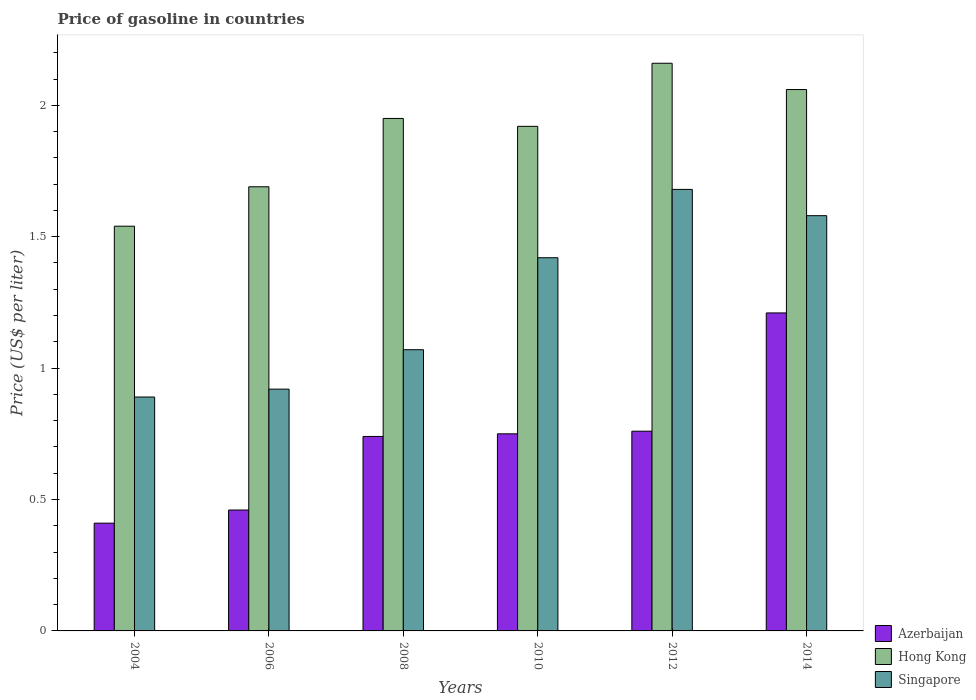How many different coloured bars are there?
Keep it short and to the point. 3. How many groups of bars are there?
Your response must be concise. 6. Are the number of bars per tick equal to the number of legend labels?
Make the answer very short. Yes. Are the number of bars on each tick of the X-axis equal?
Offer a very short reply. Yes. How many bars are there on the 2nd tick from the left?
Provide a short and direct response. 3. What is the label of the 1st group of bars from the left?
Provide a succinct answer. 2004. What is the price of gasoline in Hong Kong in 2008?
Make the answer very short. 1.95. Across all years, what is the maximum price of gasoline in Hong Kong?
Your answer should be compact. 2.16. Across all years, what is the minimum price of gasoline in Singapore?
Your answer should be very brief. 0.89. In which year was the price of gasoline in Azerbaijan maximum?
Ensure brevity in your answer.  2014. In which year was the price of gasoline in Hong Kong minimum?
Offer a terse response. 2004. What is the total price of gasoline in Hong Kong in the graph?
Give a very brief answer. 11.32. What is the difference between the price of gasoline in Azerbaijan in 2006 and that in 2010?
Your response must be concise. -0.29. What is the difference between the price of gasoline in Hong Kong in 2008 and the price of gasoline in Azerbaijan in 2014?
Provide a succinct answer. 0.74. What is the average price of gasoline in Singapore per year?
Give a very brief answer. 1.26. In the year 2012, what is the difference between the price of gasoline in Azerbaijan and price of gasoline in Singapore?
Your response must be concise. -0.92. What is the ratio of the price of gasoline in Singapore in 2010 to that in 2014?
Provide a short and direct response. 0.9. Is the price of gasoline in Singapore in 2008 less than that in 2014?
Give a very brief answer. Yes. What is the difference between the highest and the second highest price of gasoline in Hong Kong?
Provide a short and direct response. 0.1. Is the sum of the price of gasoline in Singapore in 2010 and 2012 greater than the maximum price of gasoline in Azerbaijan across all years?
Provide a short and direct response. Yes. What does the 3rd bar from the left in 2010 represents?
Make the answer very short. Singapore. What does the 3rd bar from the right in 2012 represents?
Offer a very short reply. Azerbaijan. Is it the case that in every year, the sum of the price of gasoline in Hong Kong and price of gasoline in Azerbaijan is greater than the price of gasoline in Singapore?
Give a very brief answer. Yes. How many bars are there?
Your answer should be compact. 18. Does the graph contain any zero values?
Your response must be concise. No. Does the graph contain grids?
Offer a very short reply. No. How many legend labels are there?
Offer a terse response. 3. What is the title of the graph?
Make the answer very short. Price of gasoline in countries. Does "Sierra Leone" appear as one of the legend labels in the graph?
Keep it short and to the point. No. What is the label or title of the X-axis?
Ensure brevity in your answer.  Years. What is the label or title of the Y-axis?
Offer a terse response. Price (US$ per liter). What is the Price (US$ per liter) of Azerbaijan in 2004?
Keep it short and to the point. 0.41. What is the Price (US$ per liter) in Hong Kong in 2004?
Your answer should be very brief. 1.54. What is the Price (US$ per liter) of Singapore in 2004?
Provide a short and direct response. 0.89. What is the Price (US$ per liter) in Azerbaijan in 2006?
Your answer should be compact. 0.46. What is the Price (US$ per liter) in Hong Kong in 2006?
Offer a very short reply. 1.69. What is the Price (US$ per liter) in Singapore in 2006?
Give a very brief answer. 0.92. What is the Price (US$ per liter) in Azerbaijan in 2008?
Your answer should be compact. 0.74. What is the Price (US$ per liter) of Hong Kong in 2008?
Your response must be concise. 1.95. What is the Price (US$ per liter) in Singapore in 2008?
Your answer should be very brief. 1.07. What is the Price (US$ per liter) in Azerbaijan in 2010?
Your answer should be compact. 0.75. What is the Price (US$ per liter) of Hong Kong in 2010?
Give a very brief answer. 1.92. What is the Price (US$ per liter) in Singapore in 2010?
Your answer should be very brief. 1.42. What is the Price (US$ per liter) of Azerbaijan in 2012?
Provide a succinct answer. 0.76. What is the Price (US$ per liter) of Hong Kong in 2012?
Offer a very short reply. 2.16. What is the Price (US$ per liter) of Singapore in 2012?
Offer a very short reply. 1.68. What is the Price (US$ per liter) in Azerbaijan in 2014?
Your answer should be very brief. 1.21. What is the Price (US$ per liter) of Hong Kong in 2014?
Ensure brevity in your answer.  2.06. What is the Price (US$ per liter) of Singapore in 2014?
Give a very brief answer. 1.58. Across all years, what is the maximum Price (US$ per liter) of Azerbaijan?
Ensure brevity in your answer.  1.21. Across all years, what is the maximum Price (US$ per liter) of Hong Kong?
Make the answer very short. 2.16. Across all years, what is the maximum Price (US$ per liter) of Singapore?
Your answer should be compact. 1.68. Across all years, what is the minimum Price (US$ per liter) of Azerbaijan?
Offer a very short reply. 0.41. Across all years, what is the minimum Price (US$ per liter) in Hong Kong?
Keep it short and to the point. 1.54. Across all years, what is the minimum Price (US$ per liter) in Singapore?
Make the answer very short. 0.89. What is the total Price (US$ per liter) of Azerbaijan in the graph?
Your response must be concise. 4.33. What is the total Price (US$ per liter) in Hong Kong in the graph?
Your answer should be compact. 11.32. What is the total Price (US$ per liter) of Singapore in the graph?
Offer a terse response. 7.56. What is the difference between the Price (US$ per liter) in Azerbaijan in 2004 and that in 2006?
Make the answer very short. -0.05. What is the difference between the Price (US$ per liter) of Hong Kong in 2004 and that in 2006?
Offer a terse response. -0.15. What is the difference between the Price (US$ per liter) of Singapore in 2004 and that in 2006?
Give a very brief answer. -0.03. What is the difference between the Price (US$ per liter) of Azerbaijan in 2004 and that in 2008?
Give a very brief answer. -0.33. What is the difference between the Price (US$ per liter) of Hong Kong in 2004 and that in 2008?
Your answer should be compact. -0.41. What is the difference between the Price (US$ per liter) in Singapore in 2004 and that in 2008?
Your answer should be compact. -0.18. What is the difference between the Price (US$ per liter) of Azerbaijan in 2004 and that in 2010?
Make the answer very short. -0.34. What is the difference between the Price (US$ per liter) in Hong Kong in 2004 and that in 2010?
Offer a very short reply. -0.38. What is the difference between the Price (US$ per liter) of Singapore in 2004 and that in 2010?
Offer a terse response. -0.53. What is the difference between the Price (US$ per liter) of Azerbaijan in 2004 and that in 2012?
Your answer should be compact. -0.35. What is the difference between the Price (US$ per liter) of Hong Kong in 2004 and that in 2012?
Make the answer very short. -0.62. What is the difference between the Price (US$ per liter) of Singapore in 2004 and that in 2012?
Keep it short and to the point. -0.79. What is the difference between the Price (US$ per liter) of Azerbaijan in 2004 and that in 2014?
Ensure brevity in your answer.  -0.8. What is the difference between the Price (US$ per liter) of Hong Kong in 2004 and that in 2014?
Ensure brevity in your answer.  -0.52. What is the difference between the Price (US$ per liter) in Singapore in 2004 and that in 2014?
Offer a terse response. -0.69. What is the difference between the Price (US$ per liter) of Azerbaijan in 2006 and that in 2008?
Give a very brief answer. -0.28. What is the difference between the Price (US$ per liter) in Hong Kong in 2006 and that in 2008?
Offer a very short reply. -0.26. What is the difference between the Price (US$ per liter) of Singapore in 2006 and that in 2008?
Provide a succinct answer. -0.15. What is the difference between the Price (US$ per liter) of Azerbaijan in 2006 and that in 2010?
Keep it short and to the point. -0.29. What is the difference between the Price (US$ per liter) of Hong Kong in 2006 and that in 2010?
Your answer should be compact. -0.23. What is the difference between the Price (US$ per liter) in Azerbaijan in 2006 and that in 2012?
Give a very brief answer. -0.3. What is the difference between the Price (US$ per liter) of Hong Kong in 2006 and that in 2012?
Ensure brevity in your answer.  -0.47. What is the difference between the Price (US$ per liter) in Singapore in 2006 and that in 2012?
Offer a very short reply. -0.76. What is the difference between the Price (US$ per liter) in Azerbaijan in 2006 and that in 2014?
Give a very brief answer. -0.75. What is the difference between the Price (US$ per liter) of Hong Kong in 2006 and that in 2014?
Ensure brevity in your answer.  -0.37. What is the difference between the Price (US$ per liter) of Singapore in 2006 and that in 2014?
Your response must be concise. -0.66. What is the difference between the Price (US$ per liter) of Azerbaijan in 2008 and that in 2010?
Your answer should be very brief. -0.01. What is the difference between the Price (US$ per liter) of Singapore in 2008 and that in 2010?
Offer a very short reply. -0.35. What is the difference between the Price (US$ per liter) of Azerbaijan in 2008 and that in 2012?
Offer a very short reply. -0.02. What is the difference between the Price (US$ per liter) in Hong Kong in 2008 and that in 2012?
Provide a short and direct response. -0.21. What is the difference between the Price (US$ per liter) in Singapore in 2008 and that in 2012?
Keep it short and to the point. -0.61. What is the difference between the Price (US$ per liter) of Azerbaijan in 2008 and that in 2014?
Make the answer very short. -0.47. What is the difference between the Price (US$ per liter) in Hong Kong in 2008 and that in 2014?
Ensure brevity in your answer.  -0.11. What is the difference between the Price (US$ per liter) in Singapore in 2008 and that in 2014?
Make the answer very short. -0.51. What is the difference between the Price (US$ per liter) of Azerbaijan in 2010 and that in 2012?
Your answer should be compact. -0.01. What is the difference between the Price (US$ per liter) of Hong Kong in 2010 and that in 2012?
Ensure brevity in your answer.  -0.24. What is the difference between the Price (US$ per liter) in Singapore in 2010 and that in 2012?
Give a very brief answer. -0.26. What is the difference between the Price (US$ per liter) in Azerbaijan in 2010 and that in 2014?
Provide a succinct answer. -0.46. What is the difference between the Price (US$ per liter) in Hong Kong in 2010 and that in 2014?
Offer a very short reply. -0.14. What is the difference between the Price (US$ per liter) of Singapore in 2010 and that in 2014?
Give a very brief answer. -0.16. What is the difference between the Price (US$ per liter) in Azerbaijan in 2012 and that in 2014?
Offer a terse response. -0.45. What is the difference between the Price (US$ per liter) in Singapore in 2012 and that in 2014?
Your answer should be very brief. 0.1. What is the difference between the Price (US$ per liter) in Azerbaijan in 2004 and the Price (US$ per liter) in Hong Kong in 2006?
Keep it short and to the point. -1.28. What is the difference between the Price (US$ per liter) of Azerbaijan in 2004 and the Price (US$ per liter) of Singapore in 2006?
Ensure brevity in your answer.  -0.51. What is the difference between the Price (US$ per liter) of Hong Kong in 2004 and the Price (US$ per liter) of Singapore in 2006?
Ensure brevity in your answer.  0.62. What is the difference between the Price (US$ per liter) in Azerbaijan in 2004 and the Price (US$ per liter) in Hong Kong in 2008?
Provide a short and direct response. -1.54. What is the difference between the Price (US$ per liter) in Azerbaijan in 2004 and the Price (US$ per liter) in Singapore in 2008?
Your answer should be very brief. -0.66. What is the difference between the Price (US$ per liter) in Hong Kong in 2004 and the Price (US$ per liter) in Singapore in 2008?
Make the answer very short. 0.47. What is the difference between the Price (US$ per liter) in Azerbaijan in 2004 and the Price (US$ per liter) in Hong Kong in 2010?
Offer a terse response. -1.51. What is the difference between the Price (US$ per liter) in Azerbaijan in 2004 and the Price (US$ per liter) in Singapore in 2010?
Give a very brief answer. -1.01. What is the difference between the Price (US$ per liter) of Hong Kong in 2004 and the Price (US$ per liter) of Singapore in 2010?
Provide a short and direct response. 0.12. What is the difference between the Price (US$ per liter) in Azerbaijan in 2004 and the Price (US$ per liter) in Hong Kong in 2012?
Ensure brevity in your answer.  -1.75. What is the difference between the Price (US$ per liter) in Azerbaijan in 2004 and the Price (US$ per liter) in Singapore in 2012?
Provide a succinct answer. -1.27. What is the difference between the Price (US$ per liter) of Hong Kong in 2004 and the Price (US$ per liter) of Singapore in 2012?
Ensure brevity in your answer.  -0.14. What is the difference between the Price (US$ per liter) in Azerbaijan in 2004 and the Price (US$ per liter) in Hong Kong in 2014?
Your answer should be compact. -1.65. What is the difference between the Price (US$ per liter) of Azerbaijan in 2004 and the Price (US$ per liter) of Singapore in 2014?
Offer a very short reply. -1.17. What is the difference between the Price (US$ per liter) of Hong Kong in 2004 and the Price (US$ per liter) of Singapore in 2014?
Provide a succinct answer. -0.04. What is the difference between the Price (US$ per liter) in Azerbaijan in 2006 and the Price (US$ per liter) in Hong Kong in 2008?
Offer a terse response. -1.49. What is the difference between the Price (US$ per liter) in Azerbaijan in 2006 and the Price (US$ per liter) in Singapore in 2008?
Offer a very short reply. -0.61. What is the difference between the Price (US$ per liter) in Hong Kong in 2006 and the Price (US$ per liter) in Singapore in 2008?
Your answer should be very brief. 0.62. What is the difference between the Price (US$ per liter) of Azerbaijan in 2006 and the Price (US$ per liter) of Hong Kong in 2010?
Provide a short and direct response. -1.46. What is the difference between the Price (US$ per liter) of Azerbaijan in 2006 and the Price (US$ per liter) of Singapore in 2010?
Give a very brief answer. -0.96. What is the difference between the Price (US$ per liter) of Hong Kong in 2006 and the Price (US$ per liter) of Singapore in 2010?
Offer a very short reply. 0.27. What is the difference between the Price (US$ per liter) of Azerbaijan in 2006 and the Price (US$ per liter) of Singapore in 2012?
Offer a very short reply. -1.22. What is the difference between the Price (US$ per liter) of Azerbaijan in 2006 and the Price (US$ per liter) of Singapore in 2014?
Provide a succinct answer. -1.12. What is the difference between the Price (US$ per liter) in Hong Kong in 2006 and the Price (US$ per liter) in Singapore in 2014?
Offer a very short reply. 0.11. What is the difference between the Price (US$ per liter) in Azerbaijan in 2008 and the Price (US$ per liter) in Hong Kong in 2010?
Your answer should be very brief. -1.18. What is the difference between the Price (US$ per liter) of Azerbaijan in 2008 and the Price (US$ per liter) of Singapore in 2010?
Your answer should be compact. -0.68. What is the difference between the Price (US$ per liter) in Hong Kong in 2008 and the Price (US$ per liter) in Singapore in 2010?
Provide a succinct answer. 0.53. What is the difference between the Price (US$ per liter) in Azerbaijan in 2008 and the Price (US$ per liter) in Hong Kong in 2012?
Provide a short and direct response. -1.42. What is the difference between the Price (US$ per liter) of Azerbaijan in 2008 and the Price (US$ per liter) of Singapore in 2012?
Keep it short and to the point. -0.94. What is the difference between the Price (US$ per liter) of Hong Kong in 2008 and the Price (US$ per liter) of Singapore in 2012?
Your answer should be compact. 0.27. What is the difference between the Price (US$ per liter) of Azerbaijan in 2008 and the Price (US$ per liter) of Hong Kong in 2014?
Your answer should be compact. -1.32. What is the difference between the Price (US$ per liter) of Azerbaijan in 2008 and the Price (US$ per liter) of Singapore in 2014?
Offer a terse response. -0.84. What is the difference between the Price (US$ per liter) in Hong Kong in 2008 and the Price (US$ per liter) in Singapore in 2014?
Provide a short and direct response. 0.37. What is the difference between the Price (US$ per liter) in Azerbaijan in 2010 and the Price (US$ per liter) in Hong Kong in 2012?
Provide a succinct answer. -1.41. What is the difference between the Price (US$ per liter) in Azerbaijan in 2010 and the Price (US$ per liter) in Singapore in 2012?
Ensure brevity in your answer.  -0.93. What is the difference between the Price (US$ per liter) of Hong Kong in 2010 and the Price (US$ per liter) of Singapore in 2012?
Your answer should be very brief. 0.24. What is the difference between the Price (US$ per liter) in Azerbaijan in 2010 and the Price (US$ per liter) in Hong Kong in 2014?
Your answer should be compact. -1.31. What is the difference between the Price (US$ per liter) of Azerbaijan in 2010 and the Price (US$ per liter) of Singapore in 2014?
Make the answer very short. -0.83. What is the difference between the Price (US$ per liter) in Hong Kong in 2010 and the Price (US$ per liter) in Singapore in 2014?
Make the answer very short. 0.34. What is the difference between the Price (US$ per liter) in Azerbaijan in 2012 and the Price (US$ per liter) in Singapore in 2014?
Provide a succinct answer. -0.82. What is the difference between the Price (US$ per liter) of Hong Kong in 2012 and the Price (US$ per liter) of Singapore in 2014?
Give a very brief answer. 0.58. What is the average Price (US$ per liter) of Azerbaijan per year?
Your answer should be very brief. 0.72. What is the average Price (US$ per liter) in Hong Kong per year?
Your response must be concise. 1.89. What is the average Price (US$ per liter) of Singapore per year?
Offer a terse response. 1.26. In the year 2004, what is the difference between the Price (US$ per liter) of Azerbaijan and Price (US$ per liter) of Hong Kong?
Provide a short and direct response. -1.13. In the year 2004, what is the difference between the Price (US$ per liter) in Azerbaijan and Price (US$ per liter) in Singapore?
Your response must be concise. -0.48. In the year 2004, what is the difference between the Price (US$ per liter) in Hong Kong and Price (US$ per liter) in Singapore?
Give a very brief answer. 0.65. In the year 2006, what is the difference between the Price (US$ per liter) of Azerbaijan and Price (US$ per liter) of Hong Kong?
Ensure brevity in your answer.  -1.23. In the year 2006, what is the difference between the Price (US$ per liter) of Azerbaijan and Price (US$ per liter) of Singapore?
Provide a short and direct response. -0.46. In the year 2006, what is the difference between the Price (US$ per liter) of Hong Kong and Price (US$ per liter) of Singapore?
Make the answer very short. 0.77. In the year 2008, what is the difference between the Price (US$ per liter) of Azerbaijan and Price (US$ per liter) of Hong Kong?
Give a very brief answer. -1.21. In the year 2008, what is the difference between the Price (US$ per liter) of Azerbaijan and Price (US$ per liter) of Singapore?
Make the answer very short. -0.33. In the year 2008, what is the difference between the Price (US$ per liter) of Hong Kong and Price (US$ per liter) of Singapore?
Provide a short and direct response. 0.88. In the year 2010, what is the difference between the Price (US$ per liter) of Azerbaijan and Price (US$ per liter) of Hong Kong?
Your answer should be compact. -1.17. In the year 2010, what is the difference between the Price (US$ per liter) of Azerbaijan and Price (US$ per liter) of Singapore?
Offer a very short reply. -0.67. In the year 2010, what is the difference between the Price (US$ per liter) in Hong Kong and Price (US$ per liter) in Singapore?
Offer a terse response. 0.5. In the year 2012, what is the difference between the Price (US$ per liter) of Azerbaijan and Price (US$ per liter) of Singapore?
Give a very brief answer. -0.92. In the year 2012, what is the difference between the Price (US$ per liter) of Hong Kong and Price (US$ per liter) of Singapore?
Your answer should be very brief. 0.48. In the year 2014, what is the difference between the Price (US$ per liter) of Azerbaijan and Price (US$ per liter) of Hong Kong?
Ensure brevity in your answer.  -0.85. In the year 2014, what is the difference between the Price (US$ per liter) of Azerbaijan and Price (US$ per liter) of Singapore?
Your answer should be compact. -0.37. In the year 2014, what is the difference between the Price (US$ per liter) in Hong Kong and Price (US$ per liter) in Singapore?
Ensure brevity in your answer.  0.48. What is the ratio of the Price (US$ per liter) in Azerbaijan in 2004 to that in 2006?
Offer a very short reply. 0.89. What is the ratio of the Price (US$ per liter) in Hong Kong in 2004 to that in 2006?
Offer a terse response. 0.91. What is the ratio of the Price (US$ per liter) in Singapore in 2004 to that in 2006?
Your response must be concise. 0.97. What is the ratio of the Price (US$ per liter) in Azerbaijan in 2004 to that in 2008?
Give a very brief answer. 0.55. What is the ratio of the Price (US$ per liter) in Hong Kong in 2004 to that in 2008?
Give a very brief answer. 0.79. What is the ratio of the Price (US$ per liter) of Singapore in 2004 to that in 2008?
Offer a very short reply. 0.83. What is the ratio of the Price (US$ per liter) of Azerbaijan in 2004 to that in 2010?
Provide a succinct answer. 0.55. What is the ratio of the Price (US$ per liter) in Hong Kong in 2004 to that in 2010?
Keep it short and to the point. 0.8. What is the ratio of the Price (US$ per liter) of Singapore in 2004 to that in 2010?
Your answer should be very brief. 0.63. What is the ratio of the Price (US$ per liter) in Azerbaijan in 2004 to that in 2012?
Make the answer very short. 0.54. What is the ratio of the Price (US$ per liter) of Hong Kong in 2004 to that in 2012?
Keep it short and to the point. 0.71. What is the ratio of the Price (US$ per liter) of Singapore in 2004 to that in 2012?
Keep it short and to the point. 0.53. What is the ratio of the Price (US$ per liter) of Azerbaijan in 2004 to that in 2014?
Offer a terse response. 0.34. What is the ratio of the Price (US$ per liter) of Hong Kong in 2004 to that in 2014?
Provide a short and direct response. 0.75. What is the ratio of the Price (US$ per liter) in Singapore in 2004 to that in 2014?
Offer a terse response. 0.56. What is the ratio of the Price (US$ per liter) of Azerbaijan in 2006 to that in 2008?
Provide a short and direct response. 0.62. What is the ratio of the Price (US$ per liter) in Hong Kong in 2006 to that in 2008?
Offer a terse response. 0.87. What is the ratio of the Price (US$ per liter) of Singapore in 2006 to that in 2008?
Provide a succinct answer. 0.86. What is the ratio of the Price (US$ per liter) in Azerbaijan in 2006 to that in 2010?
Keep it short and to the point. 0.61. What is the ratio of the Price (US$ per liter) of Hong Kong in 2006 to that in 2010?
Offer a very short reply. 0.88. What is the ratio of the Price (US$ per liter) in Singapore in 2006 to that in 2010?
Your answer should be compact. 0.65. What is the ratio of the Price (US$ per liter) of Azerbaijan in 2006 to that in 2012?
Your response must be concise. 0.61. What is the ratio of the Price (US$ per liter) of Hong Kong in 2006 to that in 2012?
Your response must be concise. 0.78. What is the ratio of the Price (US$ per liter) in Singapore in 2006 to that in 2012?
Your response must be concise. 0.55. What is the ratio of the Price (US$ per liter) in Azerbaijan in 2006 to that in 2014?
Offer a terse response. 0.38. What is the ratio of the Price (US$ per liter) of Hong Kong in 2006 to that in 2014?
Your answer should be compact. 0.82. What is the ratio of the Price (US$ per liter) in Singapore in 2006 to that in 2014?
Offer a very short reply. 0.58. What is the ratio of the Price (US$ per liter) in Azerbaijan in 2008 to that in 2010?
Keep it short and to the point. 0.99. What is the ratio of the Price (US$ per liter) in Hong Kong in 2008 to that in 2010?
Provide a short and direct response. 1.02. What is the ratio of the Price (US$ per liter) in Singapore in 2008 to that in 2010?
Your response must be concise. 0.75. What is the ratio of the Price (US$ per liter) of Azerbaijan in 2008 to that in 2012?
Ensure brevity in your answer.  0.97. What is the ratio of the Price (US$ per liter) in Hong Kong in 2008 to that in 2012?
Give a very brief answer. 0.9. What is the ratio of the Price (US$ per liter) of Singapore in 2008 to that in 2012?
Offer a terse response. 0.64. What is the ratio of the Price (US$ per liter) of Azerbaijan in 2008 to that in 2014?
Keep it short and to the point. 0.61. What is the ratio of the Price (US$ per liter) of Hong Kong in 2008 to that in 2014?
Make the answer very short. 0.95. What is the ratio of the Price (US$ per liter) in Singapore in 2008 to that in 2014?
Your answer should be very brief. 0.68. What is the ratio of the Price (US$ per liter) in Azerbaijan in 2010 to that in 2012?
Keep it short and to the point. 0.99. What is the ratio of the Price (US$ per liter) of Singapore in 2010 to that in 2012?
Make the answer very short. 0.85. What is the ratio of the Price (US$ per liter) of Azerbaijan in 2010 to that in 2014?
Keep it short and to the point. 0.62. What is the ratio of the Price (US$ per liter) of Hong Kong in 2010 to that in 2014?
Offer a very short reply. 0.93. What is the ratio of the Price (US$ per liter) in Singapore in 2010 to that in 2014?
Provide a succinct answer. 0.9. What is the ratio of the Price (US$ per liter) in Azerbaijan in 2012 to that in 2014?
Offer a very short reply. 0.63. What is the ratio of the Price (US$ per liter) of Hong Kong in 2012 to that in 2014?
Ensure brevity in your answer.  1.05. What is the ratio of the Price (US$ per liter) in Singapore in 2012 to that in 2014?
Keep it short and to the point. 1.06. What is the difference between the highest and the second highest Price (US$ per liter) in Azerbaijan?
Make the answer very short. 0.45. What is the difference between the highest and the second highest Price (US$ per liter) in Hong Kong?
Keep it short and to the point. 0.1. What is the difference between the highest and the lowest Price (US$ per liter) in Hong Kong?
Give a very brief answer. 0.62. What is the difference between the highest and the lowest Price (US$ per liter) of Singapore?
Make the answer very short. 0.79. 